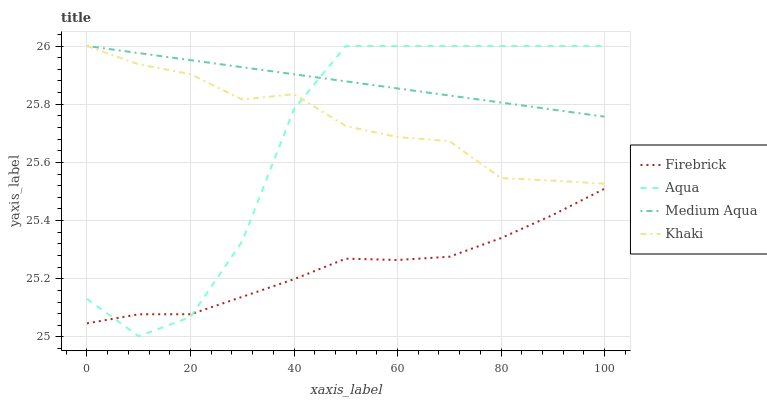Does Khaki have the minimum area under the curve?
Answer yes or no. No. Does Khaki have the maximum area under the curve?
Answer yes or no. No. Is Firebrick the smoothest?
Answer yes or no. No. Is Firebrick the roughest?
Answer yes or no. No. Does Firebrick have the lowest value?
Answer yes or no. No. Does Firebrick have the highest value?
Answer yes or no. No. Is Firebrick less than Medium Aqua?
Answer yes or no. Yes. Is Khaki greater than Firebrick?
Answer yes or no. Yes. Does Firebrick intersect Medium Aqua?
Answer yes or no. No. 